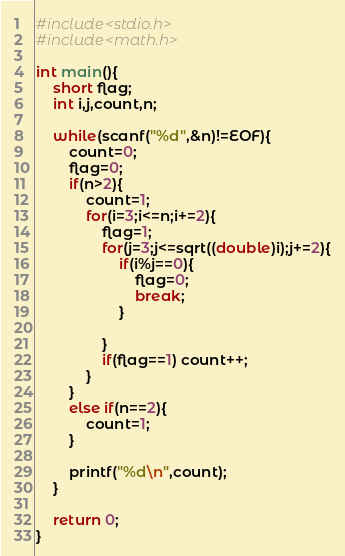Convert code to text. <code><loc_0><loc_0><loc_500><loc_500><_C_>#include<stdio.h>
#include<math.h>

int main(){
	short flag;
	int i,j,count,n;

	while(scanf("%d",&n)!=EOF){
		count=0;
		flag=0;
		if(n>2){
			count=1;
			for(i=3;i<=n;i+=2){
				flag=1;
				for(j=3;j<=sqrt((double)i);j+=2){
					if(i%j==0){
						flag=0;
						break;
					}
					
				}
				if(flag==1) count++;
			}
		}
		else if(n==2){
			count=1;
		}

		printf("%d\n",count);
	}

	return 0;
}</code> 